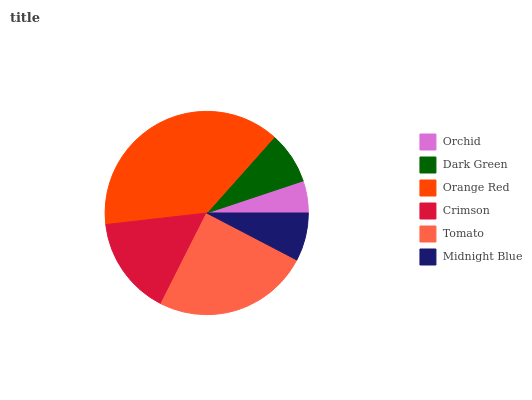Is Orchid the minimum?
Answer yes or no. Yes. Is Orange Red the maximum?
Answer yes or no. Yes. Is Dark Green the minimum?
Answer yes or no. No. Is Dark Green the maximum?
Answer yes or no. No. Is Dark Green greater than Orchid?
Answer yes or no. Yes. Is Orchid less than Dark Green?
Answer yes or no. Yes. Is Orchid greater than Dark Green?
Answer yes or no. No. Is Dark Green less than Orchid?
Answer yes or no. No. Is Crimson the high median?
Answer yes or no. Yes. Is Dark Green the low median?
Answer yes or no. Yes. Is Orange Red the high median?
Answer yes or no. No. Is Tomato the low median?
Answer yes or no. No. 